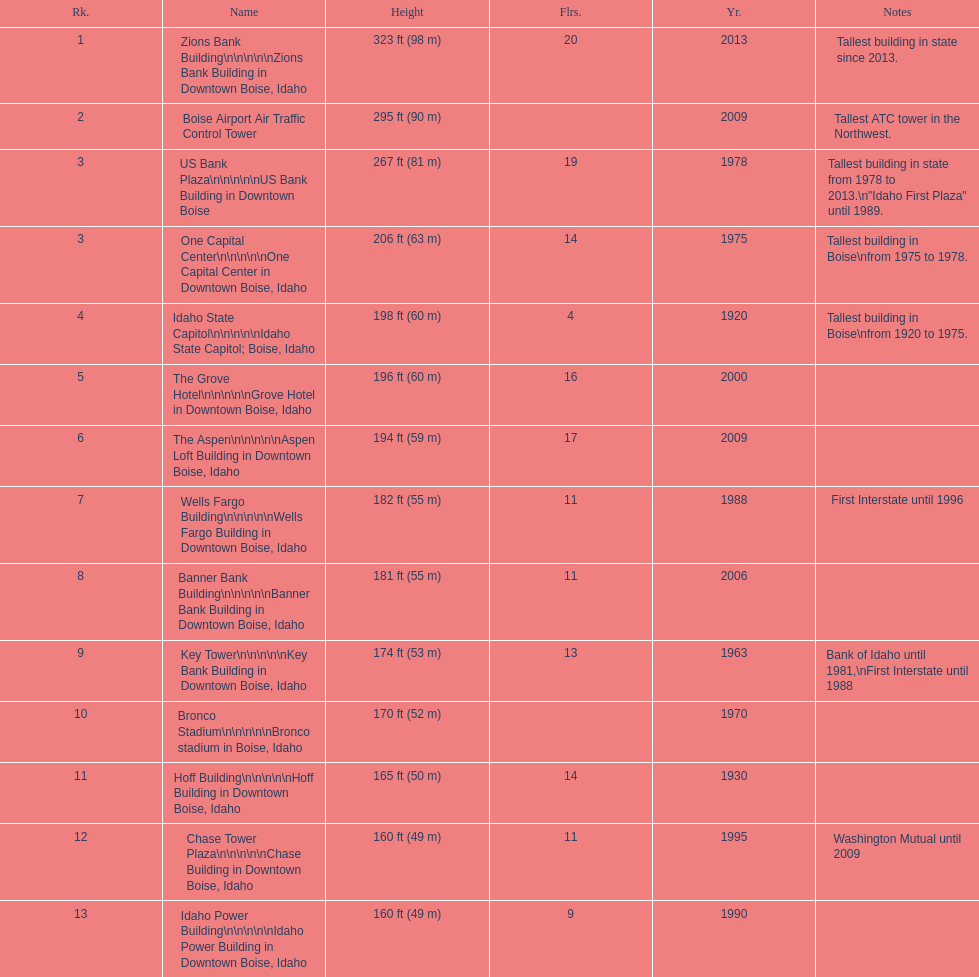Which building has the most floors according to this chart? Zions Bank Building. 